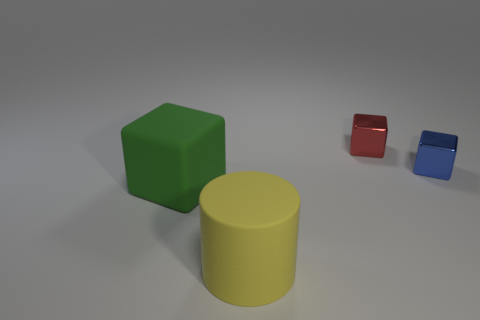What is the color of the rubber object that is the same shape as the red shiny object?
Give a very brief answer. Green. What number of small blue shiny things are the same shape as the red object?
Your response must be concise. 1. The object that is both in front of the small red shiny object and on the right side of the yellow object has what shape?
Provide a short and direct response. Cube. There is a block in front of the small thing that is to the right of the tiny shiny cube behind the tiny blue metallic thing; what is its color?
Provide a succinct answer. Green. Is the number of green matte things that are to the right of the large green rubber thing less than the number of small red objects?
Offer a very short reply. Yes. Do the big matte object to the left of the yellow rubber object and the blue object behind the big matte cylinder have the same shape?
Offer a terse response. Yes. How many things are either cubes left of the tiny red object or small objects?
Make the answer very short. 3. Is there a big green block behind the block that is to the left of the large rubber thing to the right of the rubber cube?
Provide a short and direct response. No. Is the number of large yellow rubber things left of the yellow cylinder less than the number of tiny blue metal blocks that are to the left of the red metal cube?
Offer a very short reply. No. What is the color of the cube that is the same material as the large cylinder?
Provide a short and direct response. Green. 